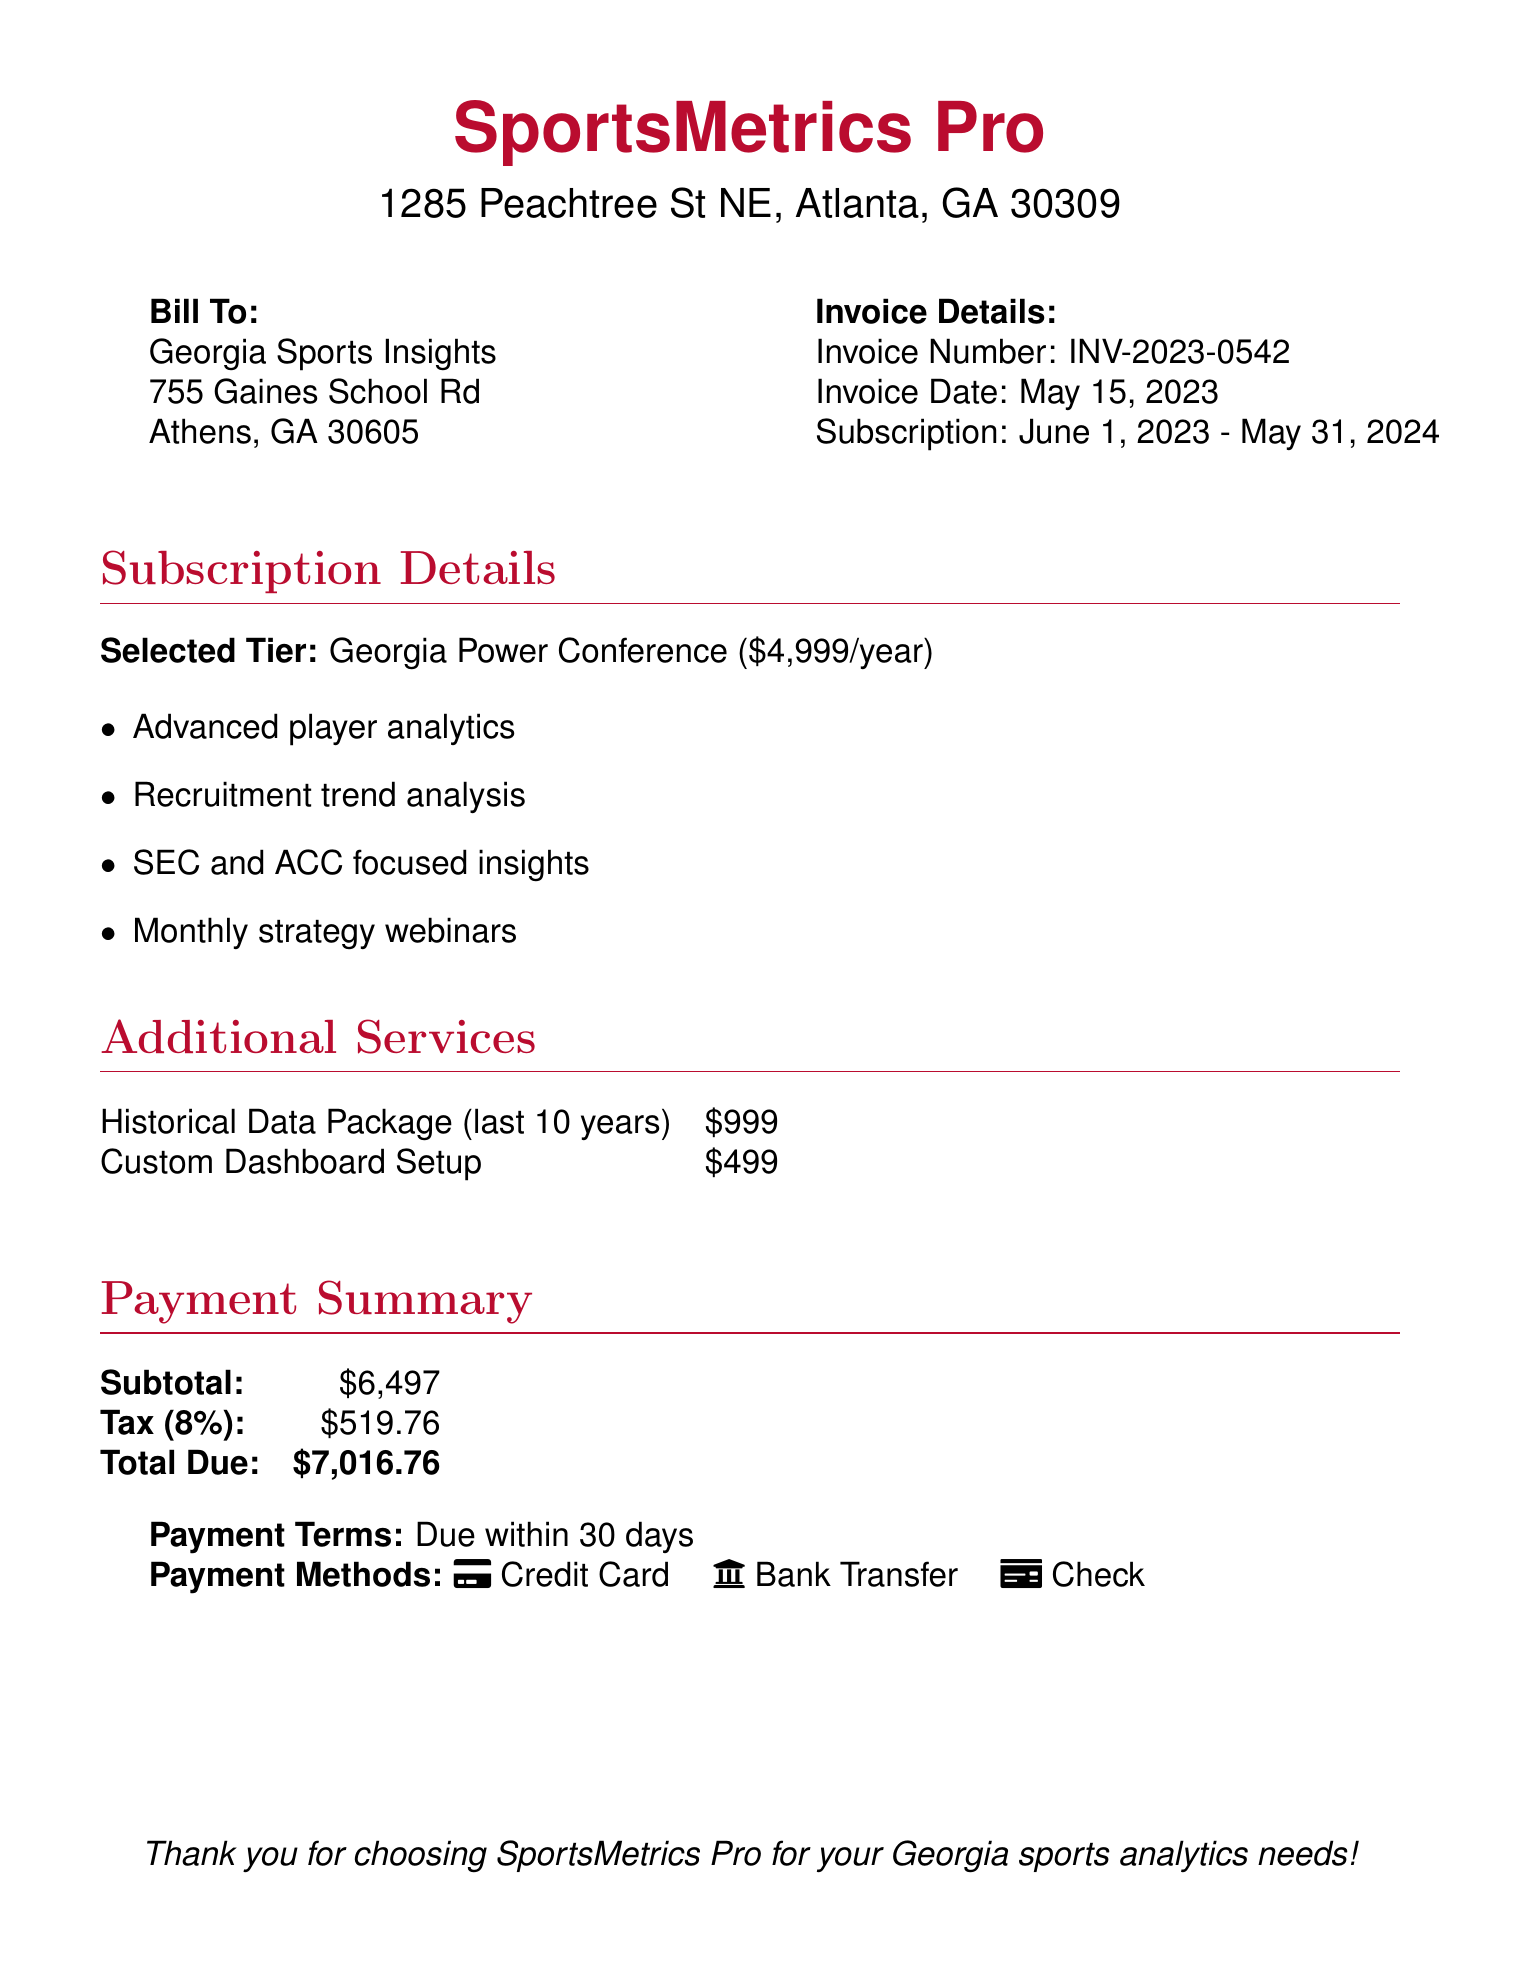What is the name of the software? The name of the software, as mentioned in the document, is SportsMetrics Pro.
Answer: SportsMetrics Pro What is the invoice number? The invoice number is explicitly stated in the document to be INV-2023-0542.
Answer: INV-2023-0542 What is the total due amount? The document specifies the total due amount at the bottom, which is $7,016.76.
Answer: $7,016.76 What is the duration of the subscription? The duration of the subscription mentioned is from June 1, 2023, to May 31, 2024.
Answer: June 1, 2023 - May 31, 2024 What additional service has the highest cost? The historical data package is listed as $999, which is the highest cost among the additional services.
Answer: Historical Data Package What features are included in the Georgia Power Conference tier? The features include advanced player analytics, recruitment trend analysis, SEC and ACC focused insights, and monthly strategy webinars.
Answer: Advanced player analytics, recruitment trend analysis, SEC and ACC focused insights, monthly strategy webinars What is the tax percentage applied? The document states that the tax percentage is 8%.
Answer: 8% What are the payment methods listed? The listed payment methods include credit card, bank transfer, and check.
Answer: Credit Card, Bank Transfer, Check When is the payment due? The document specifies that the payment is due within 30 days.
Answer: 30 days 